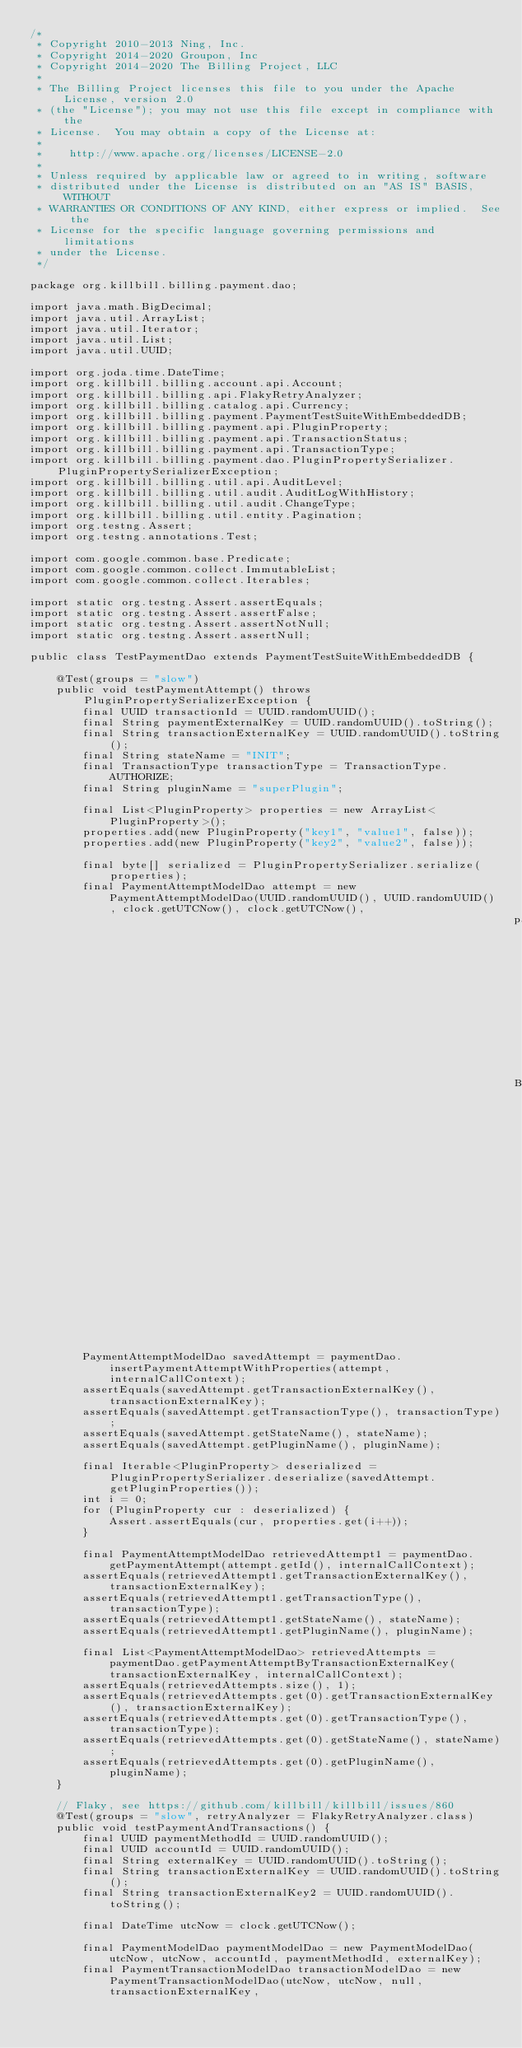Convert code to text. <code><loc_0><loc_0><loc_500><loc_500><_Java_>/*
 * Copyright 2010-2013 Ning, Inc.
 * Copyright 2014-2020 Groupon, Inc
 * Copyright 2014-2020 The Billing Project, LLC
 *
 * The Billing Project licenses this file to you under the Apache License, version 2.0
 * (the "License"); you may not use this file except in compliance with the
 * License.  You may obtain a copy of the License at:
 *
 *    http://www.apache.org/licenses/LICENSE-2.0
 *
 * Unless required by applicable law or agreed to in writing, software
 * distributed under the License is distributed on an "AS IS" BASIS, WITHOUT
 * WARRANTIES OR CONDITIONS OF ANY KIND, either express or implied.  See the
 * License for the specific language governing permissions and limitations
 * under the License.
 */

package org.killbill.billing.payment.dao;

import java.math.BigDecimal;
import java.util.ArrayList;
import java.util.Iterator;
import java.util.List;
import java.util.UUID;

import org.joda.time.DateTime;
import org.killbill.billing.account.api.Account;
import org.killbill.billing.api.FlakyRetryAnalyzer;
import org.killbill.billing.catalog.api.Currency;
import org.killbill.billing.payment.PaymentTestSuiteWithEmbeddedDB;
import org.killbill.billing.payment.api.PluginProperty;
import org.killbill.billing.payment.api.TransactionStatus;
import org.killbill.billing.payment.api.TransactionType;
import org.killbill.billing.payment.dao.PluginPropertySerializer.PluginPropertySerializerException;
import org.killbill.billing.util.api.AuditLevel;
import org.killbill.billing.util.audit.AuditLogWithHistory;
import org.killbill.billing.util.audit.ChangeType;
import org.killbill.billing.util.entity.Pagination;
import org.testng.Assert;
import org.testng.annotations.Test;

import com.google.common.base.Predicate;
import com.google.common.collect.ImmutableList;
import com.google.common.collect.Iterables;

import static org.testng.Assert.assertEquals;
import static org.testng.Assert.assertFalse;
import static org.testng.Assert.assertNotNull;
import static org.testng.Assert.assertNull;

public class TestPaymentDao extends PaymentTestSuiteWithEmbeddedDB {

    @Test(groups = "slow")
    public void testPaymentAttempt() throws PluginPropertySerializerException {
        final UUID transactionId = UUID.randomUUID();
        final String paymentExternalKey = UUID.randomUUID().toString();
        final String transactionExternalKey = UUID.randomUUID().toString();
        final String stateName = "INIT";
        final TransactionType transactionType = TransactionType.AUTHORIZE;
        final String pluginName = "superPlugin";

        final List<PluginProperty> properties = new ArrayList<PluginProperty>();
        properties.add(new PluginProperty("key1", "value1", false));
        properties.add(new PluginProperty("key2", "value2", false));

        final byte[] serialized = PluginPropertySerializer.serialize(properties);
        final PaymentAttemptModelDao attempt = new PaymentAttemptModelDao(UUID.randomUUID(), UUID.randomUUID(), clock.getUTCNow(), clock.getUTCNow(),
                                                                          paymentExternalKey, transactionId, transactionExternalKey, transactionType, stateName,
                                                                          BigDecimal.ZERO, Currency.ALL, ImmutableList.<String>of(pluginName), serialized);

        PaymentAttemptModelDao savedAttempt = paymentDao.insertPaymentAttemptWithProperties(attempt, internalCallContext);
        assertEquals(savedAttempt.getTransactionExternalKey(), transactionExternalKey);
        assertEquals(savedAttempt.getTransactionType(), transactionType);
        assertEquals(savedAttempt.getStateName(), stateName);
        assertEquals(savedAttempt.getPluginName(), pluginName);

        final Iterable<PluginProperty> deserialized = PluginPropertySerializer.deserialize(savedAttempt.getPluginProperties());
        int i = 0;
        for (PluginProperty cur : deserialized) {
            Assert.assertEquals(cur, properties.get(i++));
        }

        final PaymentAttemptModelDao retrievedAttempt1 = paymentDao.getPaymentAttempt(attempt.getId(), internalCallContext);
        assertEquals(retrievedAttempt1.getTransactionExternalKey(), transactionExternalKey);
        assertEquals(retrievedAttempt1.getTransactionType(), transactionType);
        assertEquals(retrievedAttempt1.getStateName(), stateName);
        assertEquals(retrievedAttempt1.getPluginName(), pluginName);

        final List<PaymentAttemptModelDao> retrievedAttempts = paymentDao.getPaymentAttemptByTransactionExternalKey(transactionExternalKey, internalCallContext);
        assertEquals(retrievedAttempts.size(), 1);
        assertEquals(retrievedAttempts.get(0).getTransactionExternalKey(), transactionExternalKey);
        assertEquals(retrievedAttempts.get(0).getTransactionType(), transactionType);
        assertEquals(retrievedAttempts.get(0).getStateName(), stateName);
        assertEquals(retrievedAttempts.get(0).getPluginName(), pluginName);
    }

    // Flaky, see https://github.com/killbill/killbill/issues/860
    @Test(groups = "slow", retryAnalyzer = FlakyRetryAnalyzer.class)
    public void testPaymentAndTransactions() {
        final UUID paymentMethodId = UUID.randomUUID();
        final UUID accountId = UUID.randomUUID();
        final String externalKey = UUID.randomUUID().toString();
        final String transactionExternalKey = UUID.randomUUID().toString();
        final String transactionExternalKey2 = UUID.randomUUID().toString();

        final DateTime utcNow = clock.getUTCNow();

        final PaymentModelDao paymentModelDao = new PaymentModelDao(utcNow, utcNow, accountId, paymentMethodId, externalKey);
        final PaymentTransactionModelDao transactionModelDao = new PaymentTransactionModelDao(utcNow, utcNow, null, transactionExternalKey,</code> 